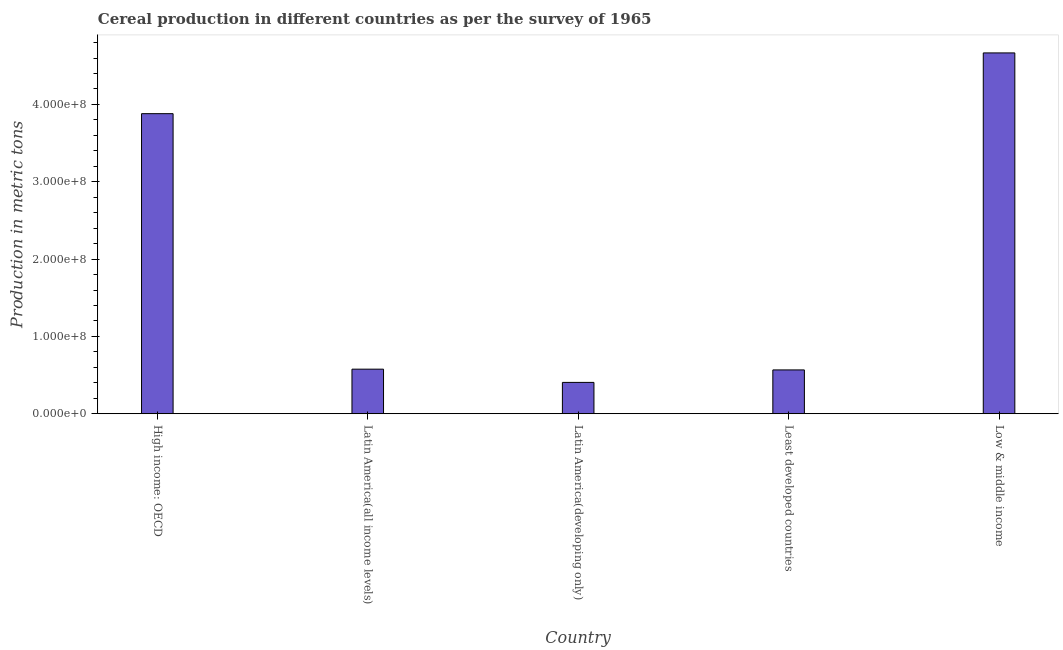Does the graph contain any zero values?
Offer a terse response. No. What is the title of the graph?
Provide a short and direct response. Cereal production in different countries as per the survey of 1965. What is the label or title of the X-axis?
Provide a succinct answer. Country. What is the label or title of the Y-axis?
Give a very brief answer. Production in metric tons. What is the cereal production in Least developed countries?
Provide a succinct answer. 5.67e+07. Across all countries, what is the maximum cereal production?
Make the answer very short. 4.67e+08. Across all countries, what is the minimum cereal production?
Keep it short and to the point. 4.05e+07. In which country was the cereal production minimum?
Your answer should be very brief. Latin America(developing only). What is the sum of the cereal production?
Make the answer very short. 1.01e+09. What is the difference between the cereal production in Latin America(all income levels) and Least developed countries?
Provide a succinct answer. 9.68e+05. What is the average cereal production per country?
Your response must be concise. 2.02e+08. What is the median cereal production?
Your answer should be very brief. 5.76e+07. In how many countries, is the cereal production greater than 400000000 metric tons?
Offer a very short reply. 1. What is the ratio of the cereal production in Latin America(all income levels) to that in Least developed countries?
Provide a short and direct response. 1.02. Is the cereal production in High income: OECD less than that in Latin America(all income levels)?
Give a very brief answer. No. What is the difference between the highest and the second highest cereal production?
Ensure brevity in your answer.  7.86e+07. Is the sum of the cereal production in High income: OECD and Latin America(all income levels) greater than the maximum cereal production across all countries?
Your answer should be compact. No. What is the difference between the highest and the lowest cereal production?
Your answer should be compact. 4.26e+08. Are all the bars in the graph horizontal?
Offer a terse response. No. How many countries are there in the graph?
Your answer should be very brief. 5. What is the difference between two consecutive major ticks on the Y-axis?
Make the answer very short. 1.00e+08. Are the values on the major ticks of Y-axis written in scientific E-notation?
Ensure brevity in your answer.  Yes. What is the Production in metric tons of High income: OECD?
Your answer should be very brief. 3.88e+08. What is the Production in metric tons of Latin America(all income levels)?
Offer a terse response. 5.76e+07. What is the Production in metric tons in Latin America(developing only)?
Keep it short and to the point. 4.05e+07. What is the Production in metric tons of Least developed countries?
Provide a short and direct response. 5.67e+07. What is the Production in metric tons of Low & middle income?
Ensure brevity in your answer.  4.67e+08. What is the difference between the Production in metric tons in High income: OECD and Latin America(all income levels)?
Make the answer very short. 3.30e+08. What is the difference between the Production in metric tons in High income: OECD and Latin America(developing only)?
Make the answer very short. 3.48e+08. What is the difference between the Production in metric tons in High income: OECD and Least developed countries?
Give a very brief answer. 3.31e+08. What is the difference between the Production in metric tons in High income: OECD and Low & middle income?
Keep it short and to the point. -7.86e+07. What is the difference between the Production in metric tons in Latin America(all income levels) and Latin America(developing only)?
Offer a terse response. 1.71e+07. What is the difference between the Production in metric tons in Latin America(all income levels) and Least developed countries?
Keep it short and to the point. 9.68e+05. What is the difference between the Production in metric tons in Latin America(all income levels) and Low & middle income?
Provide a short and direct response. -4.09e+08. What is the difference between the Production in metric tons in Latin America(developing only) and Least developed countries?
Provide a short and direct response. -1.61e+07. What is the difference between the Production in metric tons in Latin America(developing only) and Low & middle income?
Your response must be concise. -4.26e+08. What is the difference between the Production in metric tons in Least developed countries and Low & middle income?
Your response must be concise. -4.10e+08. What is the ratio of the Production in metric tons in High income: OECD to that in Latin America(all income levels)?
Provide a succinct answer. 6.73. What is the ratio of the Production in metric tons in High income: OECD to that in Latin America(developing only)?
Offer a very short reply. 9.57. What is the ratio of the Production in metric tons in High income: OECD to that in Least developed countries?
Provide a succinct answer. 6.85. What is the ratio of the Production in metric tons in High income: OECD to that in Low & middle income?
Offer a terse response. 0.83. What is the ratio of the Production in metric tons in Latin America(all income levels) to that in Latin America(developing only)?
Keep it short and to the point. 1.42. What is the ratio of the Production in metric tons in Latin America(all income levels) to that in Least developed countries?
Ensure brevity in your answer.  1.02. What is the ratio of the Production in metric tons in Latin America(all income levels) to that in Low & middle income?
Your response must be concise. 0.12. What is the ratio of the Production in metric tons in Latin America(developing only) to that in Least developed countries?
Offer a very short reply. 0.71. What is the ratio of the Production in metric tons in Latin America(developing only) to that in Low & middle income?
Give a very brief answer. 0.09. What is the ratio of the Production in metric tons in Least developed countries to that in Low & middle income?
Your answer should be very brief. 0.12. 